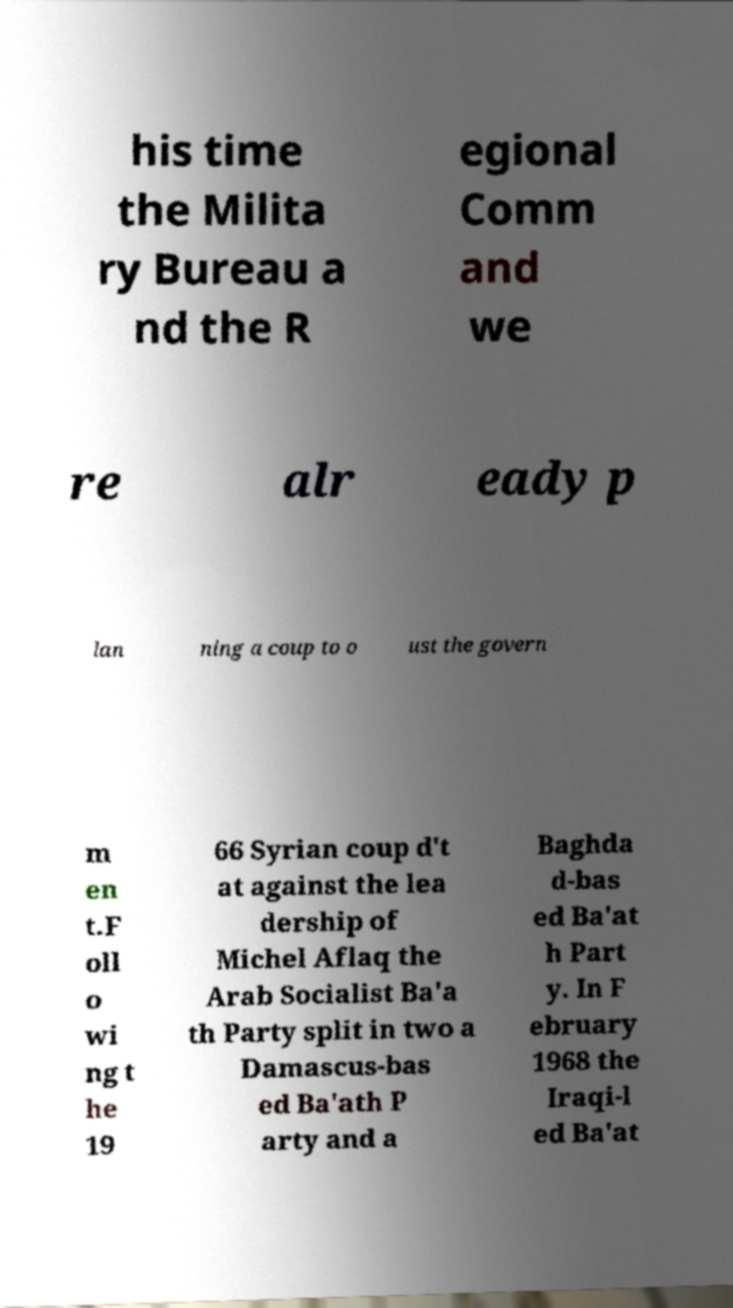Can you accurately transcribe the text from the provided image for me? his time the Milita ry Bureau a nd the R egional Comm and we re alr eady p lan ning a coup to o ust the govern m en t.F oll o wi ng t he 19 66 Syrian coup d't at against the lea dership of Michel Aflaq the Arab Socialist Ba'a th Party split in two a Damascus-bas ed Ba'ath P arty and a Baghda d-bas ed Ba'at h Part y. In F ebruary 1968 the Iraqi-l ed Ba'at 